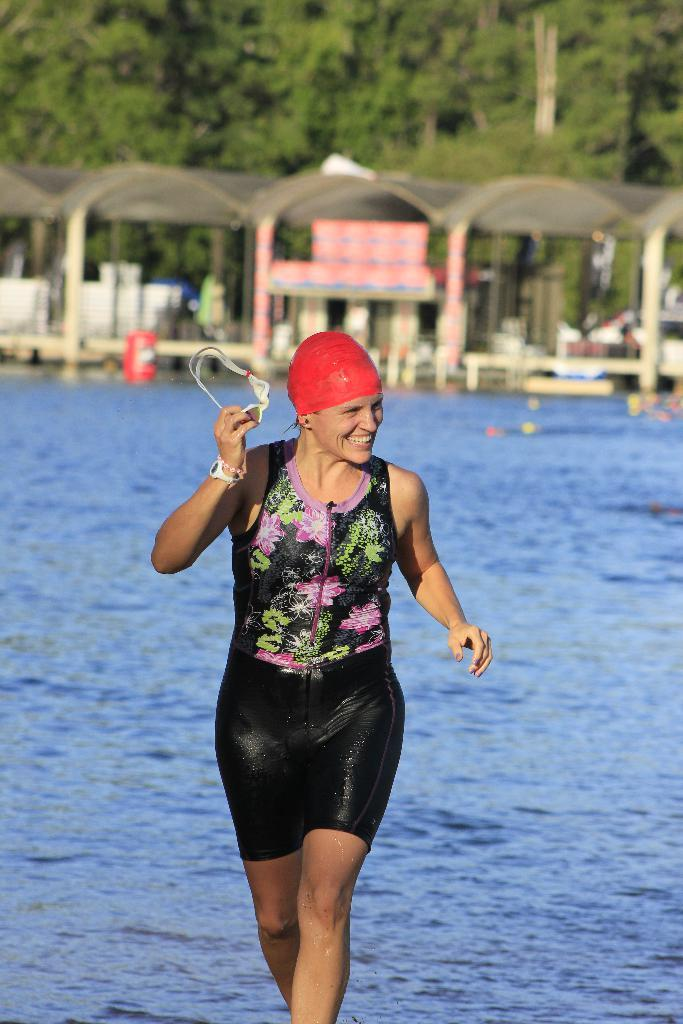Who is present in the image? There is a woman in the image. What is the woman wearing? The woman is wearing a swimming dress and a red cap. What is the woman holding in her hand? The woman is holding glasses in her hand. What can be seen in the background of the image? There are shelters and trees in the background of the image. What type of voice can be heard coming from the woman in the image? There is no voice present in the image, as it is a still photograph. What unit of measurement is used to determine the woman's height in the image? There is no unit of measurement provided in the image, as it is a still photograph. 